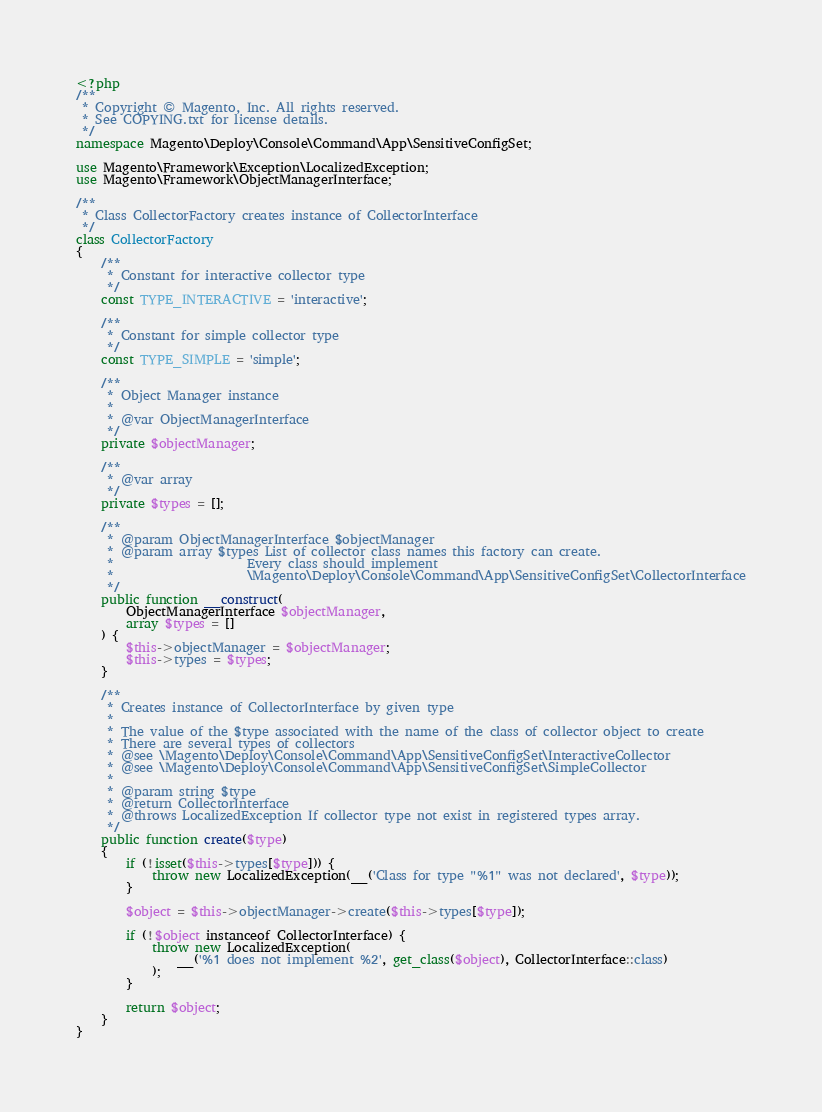Convert code to text. <code><loc_0><loc_0><loc_500><loc_500><_PHP_><?php
/**
 * Copyright © Magento, Inc. All rights reserved.
 * See COPYING.txt for license details.
 */
namespace Magento\Deploy\Console\Command\App\SensitiveConfigSet;

use Magento\Framework\Exception\LocalizedException;
use Magento\Framework\ObjectManagerInterface;

/**
 * Class CollectorFactory creates instance of CollectorInterface
 */
class CollectorFactory
{
    /**
     * Constant for interactive collector type
     */
    const TYPE_INTERACTIVE = 'interactive';

    /**
     * Constant for simple collector type
     */
    const TYPE_SIMPLE = 'simple';

    /**
     * Object Manager instance
     *
     * @var ObjectManagerInterface
     */
    private $objectManager;

    /**
     * @var array
     */
    private $types = [];

    /**
     * @param ObjectManagerInterface $objectManager
     * @param array $types List of collector class names this factory can create.
     *                     Every class should implement
     *                     \Magento\Deploy\Console\Command\App\SensitiveConfigSet\CollectorInterface
     */
    public function __construct(
        ObjectManagerInterface $objectManager,
        array $types = []
    ) {
        $this->objectManager = $objectManager;
        $this->types = $types;
    }

    /**
     * Creates instance of CollectorInterface by given type
     *
     * The value of the $type associated with the name of the class of collector object to create
     * There are several types of collectors
     * @see \Magento\Deploy\Console\Command\App\SensitiveConfigSet\InteractiveCollector
     * @see \Magento\Deploy\Console\Command\App\SensitiveConfigSet\SimpleCollector
     *
     * @param string $type
     * @return CollectorInterface
     * @throws LocalizedException If collector type not exist in registered types array.
     */
    public function create($type)
    {
        if (!isset($this->types[$type])) {
            throw new LocalizedException(__('Class for type "%1" was not declared', $type));
        }

        $object = $this->objectManager->create($this->types[$type]);

        if (!$object instanceof CollectorInterface) {
            throw new LocalizedException(
                __('%1 does not implement %2', get_class($object), CollectorInterface::class)
            );
        }

        return $object;
    }
}
</code> 